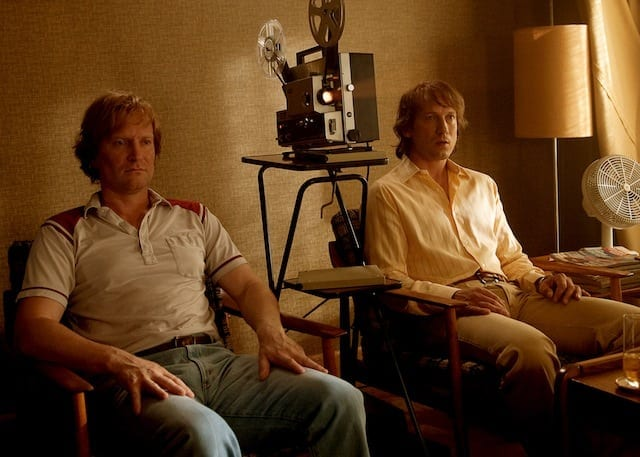What is this photo about? This photo captures two individuals in a contemplative moment, set against a backdrop that includes a film projector and a warm, ambient lit room suggesting a cinematic setting. The man on the left is dressed in a red and white striped shirt with blue jeans, adopting a relaxed posture, which along with his focused expression, hints at a casual yet potentially professional engagement. Opposite him, another person wearing a yellow shirt contributes to the serene and thoughtful atmosphere. Together, they seem to be involved in a setting that could be related to film review or discussion, emphasized by the presence of the projector, lending an artistic overtone to the scene. 